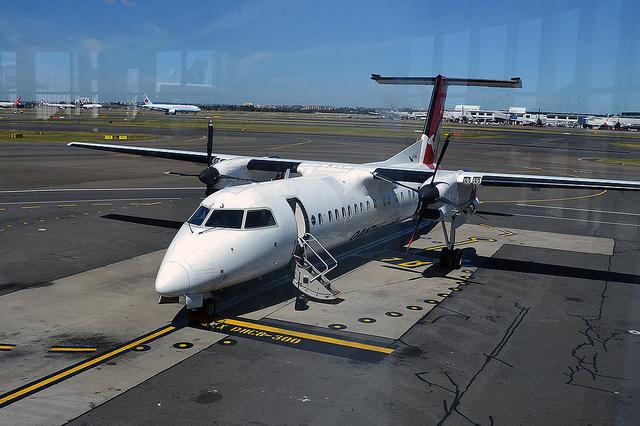Is there anyone inside the plane?
Quick response, please. Yes. Are there initials on the plane?
Concise answer only. No. Where do you think the location of the photographer of this photo is?
Concise answer only. Airport. Is the plane in the air or on the ground?
Keep it brief. Ground. 